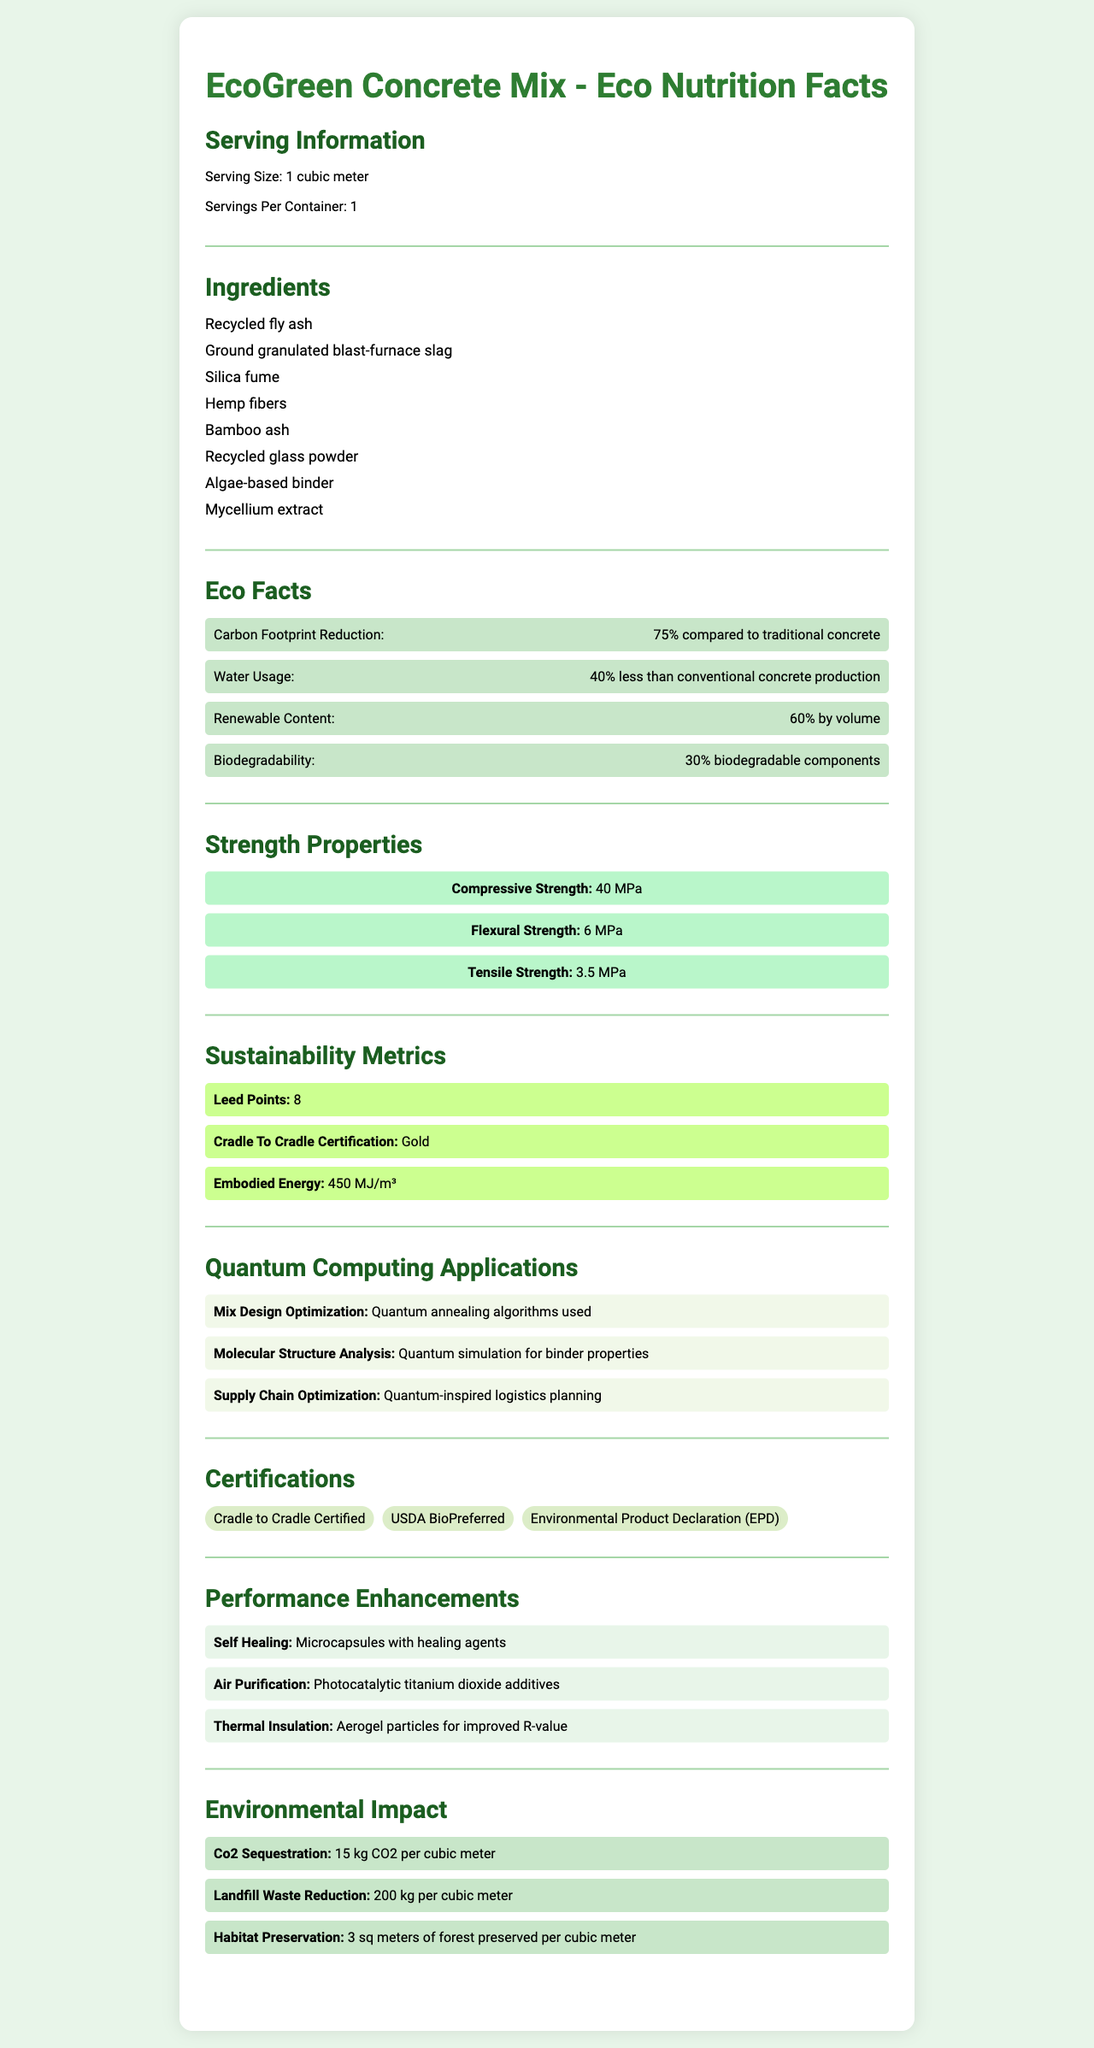what is the serving size for EcoGreen Concrete Mix? The serving size is explicitly mentioned in the "Serving Information" section.
Answer: 1 cubic meter which eco-friendly ingredient helps with compressive strength? Silica fume is listed among the ingredients and is well-known in materials science for contributing to the compressive strength of the concrete.
Answer: Silica fume how many LEED points does EcoGreen Concrete Mix contribute to? The document's "Sustainability Metrics" section states that the product contributes 8 LEED points.
Answer: 8 what is the tensile strength of this product? The tensile strength is listed in the "Strength Properties" section as 3.5 MPa.
Answer: 3.5 MPa what percentage of the content is biodegradable? The "Eco Facts" section specifies that 30% of the contents are biodegradable.
Answer: 30% what quantum computing technique is used for mix design optimization? A. Quantum gates B. Quantum annealing C. Quantum teleportation "Quantum annealing algorithms used" is clearly mentioned under the "Quantum Computing Applications" section for mix design optimization.
Answer: B which certification is not listed in the document? i. Cradle to Cradle Certified ii. USDA BioPreferred iii. LEED Gold iv. Environmental Product Declaration LEED Gold certification is not mentioned. The listed certifications include Cradle to Cradle Certified, USDA BioPreferred, and Environmental Product Declaration.
Answer: iii is the EcoGreen Concrete Mix water usage higher or lower than conventional concrete? The "Eco Facts" section notes that the product uses 40% less water than conventional concrete production.
Answer: Lower summarize the main eco-friendly aspects and sustainability metrics of the EcoGreen Concrete Mix. This is a summary of the document based on the information provided under various sections including eco facts, sustainability metrics, ingredients, and performance enhancements.
Answer: The EcoGreen Concrete Mix is a sustainable building material that reduces the carbon footprint by 75%, uses 40% less water, contains 60% renewable content, and includes biodegradable components. It contributes 8 LEED points, has received Gold Cradle to Cradle Certification, and has an embodied energy of 450 MJ/m³. The product features an array of eco-friendly ingredients like recycled fly ash, hemp fibers, and algae-based binder. Quantum computing applications are utilized for mix optimization and molecular analysis. The material also provides additional benefits such as self-healing, air purification, and thermal insulation. what is the specific reduction in landfill waste per cubic meter of EcoGreen Concrete Mix? The "Environmental Impact" section indicates a landfill waste reduction of 200 kg per cubic meter.
Answer: 200 kg per cubic meter what is the carbon footprint reduction achieved by using the EcoGreen Concrete Mix? The "Eco Facts" section mentions that the carbon footprint reduction is 75% compared to traditional concrete.
Answer: 75% how is habitat preservation quantified for this product? The "Environmental Impact" section details that each cubic meter of EcoGreen Concrete Mix preserves 3 sq meters of forest.
Answer: 3 sq meters of forest preserved per cubic meter what type of particles are used for thermal insulation enhancement? The "Performance Enhancements" section mentions aerogel particles as used for improved R-value (thermal insulation).
Answer: Aerogel particles what is the purpose of microcapsules in this concrete mix? The section on "Performance Enhancements" details that microcapsules with healing agents are included for self-healing purposes.
Answer: Self-healing how much CO2 can this concrete mix sequester per cubic meter? The "Environmental Impact" section specifies that the mix sequesters 15 kg CO2 per cubic meter.
Answer: 15 kg CO2 per cubic meter which quantum computing application is not mentioned in the document? A. Supply chain optimization B. Quantum key distribution C. Molecular structure analysis Quantum key distribution is not mentioned. The document details applications like supply chain optimization and molecular structure analysis.
Answer: B what is the meaning of embodied energy in the context of this concrete mix? While the document states the embodied energy is 450 MJ/m³, it does not provide an explanation of what embodied energy means in this context.
Answer: Not enough information 